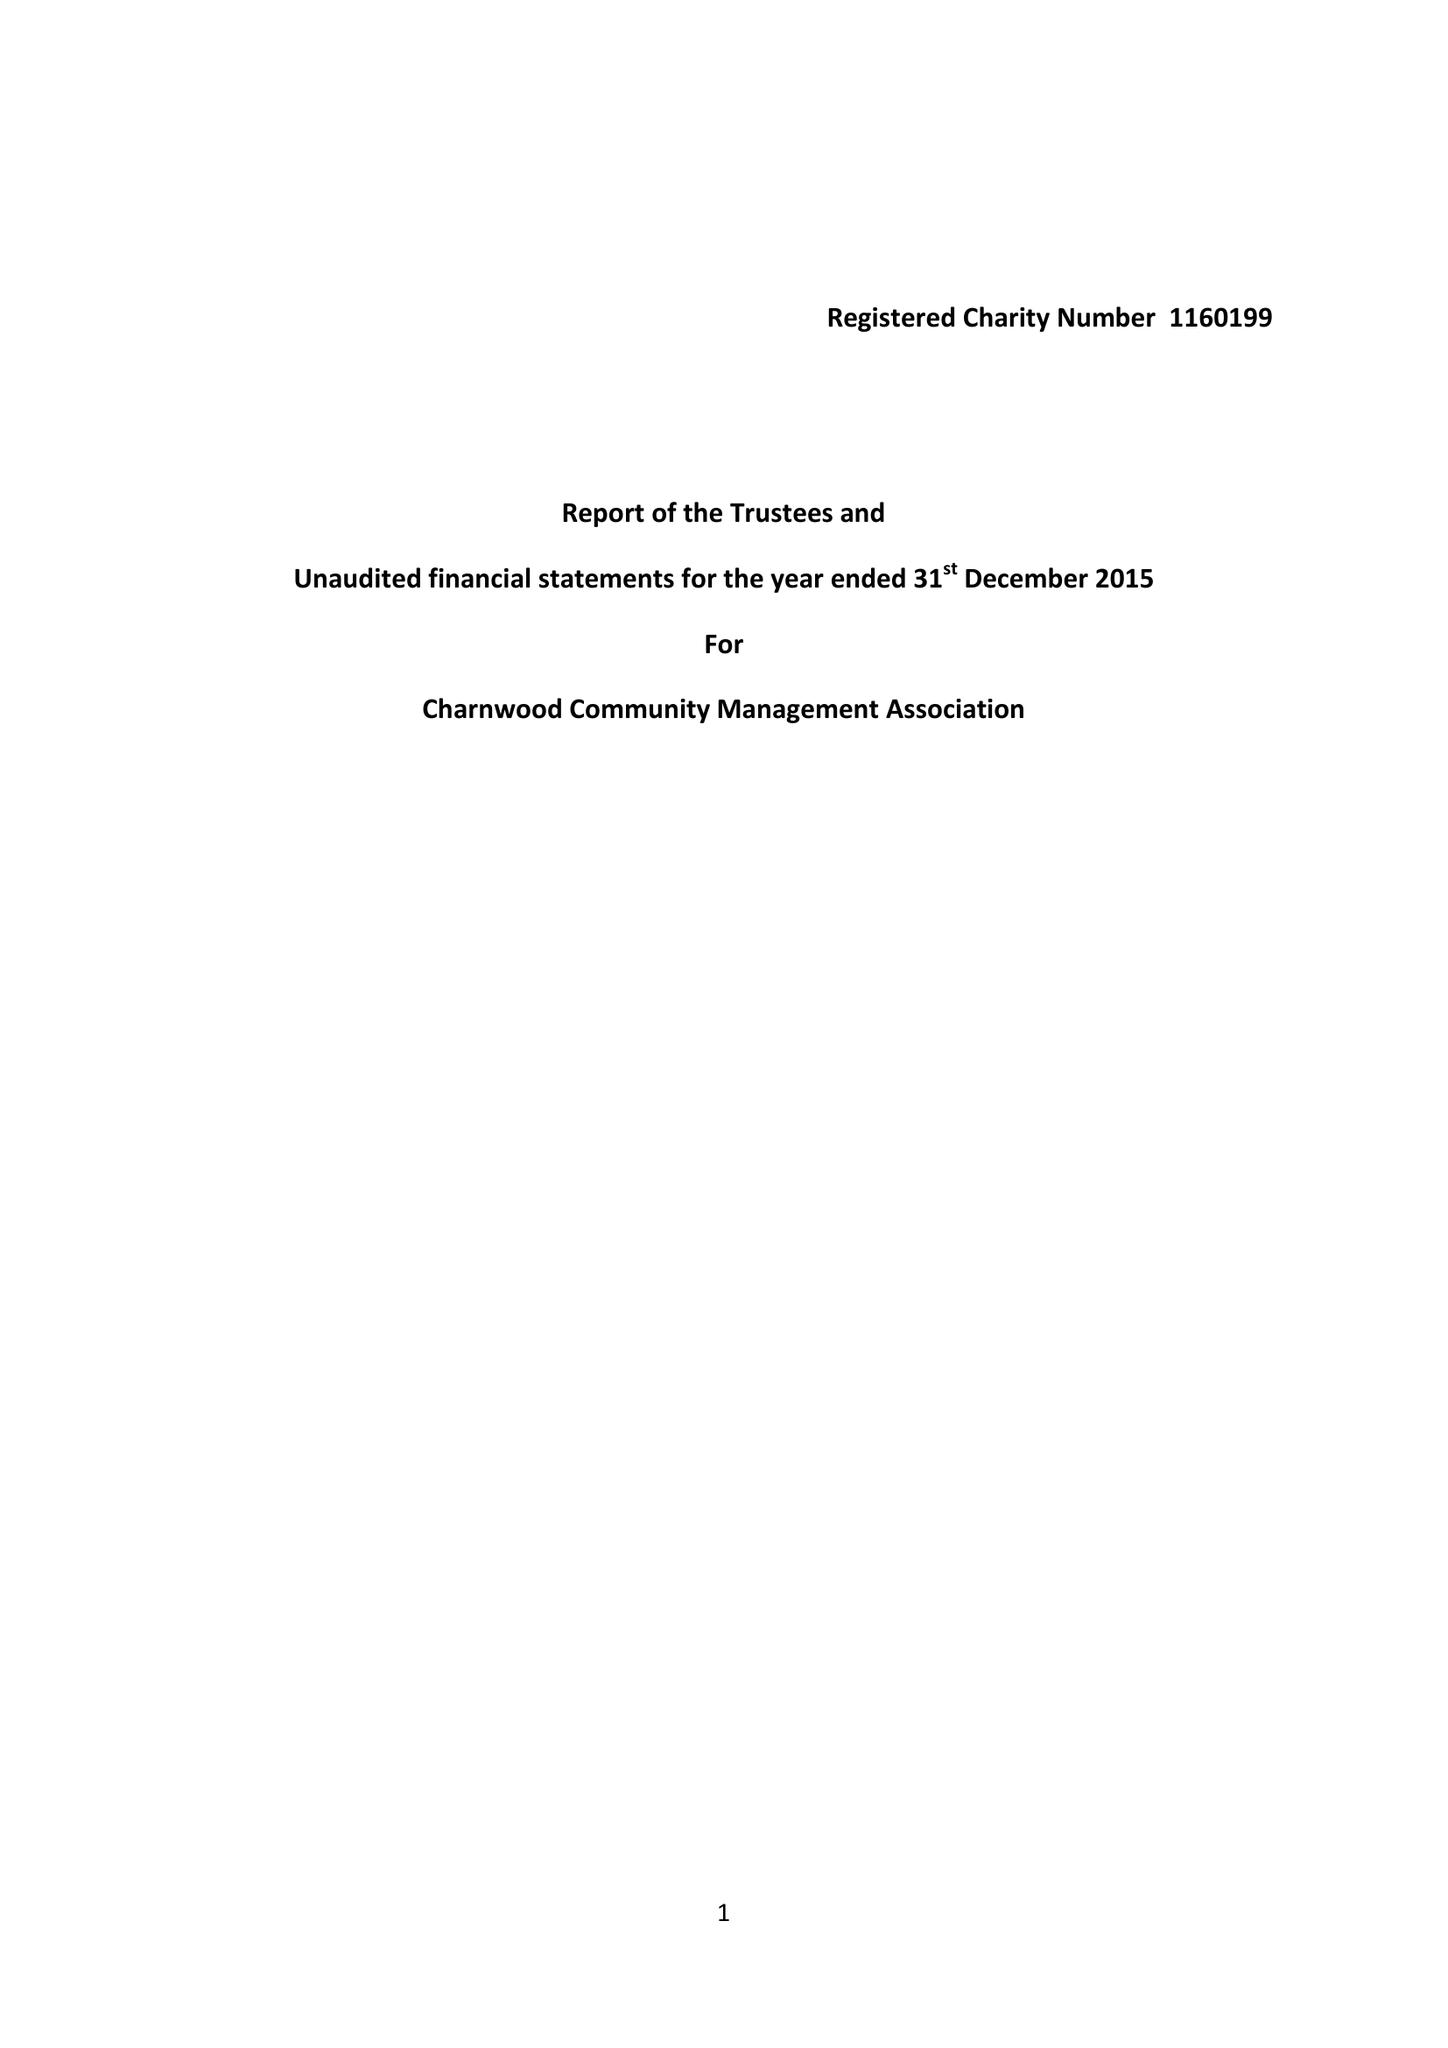What is the value for the address__street_line?
Answer the question using a single word or phrase. 23 WEST HILL 